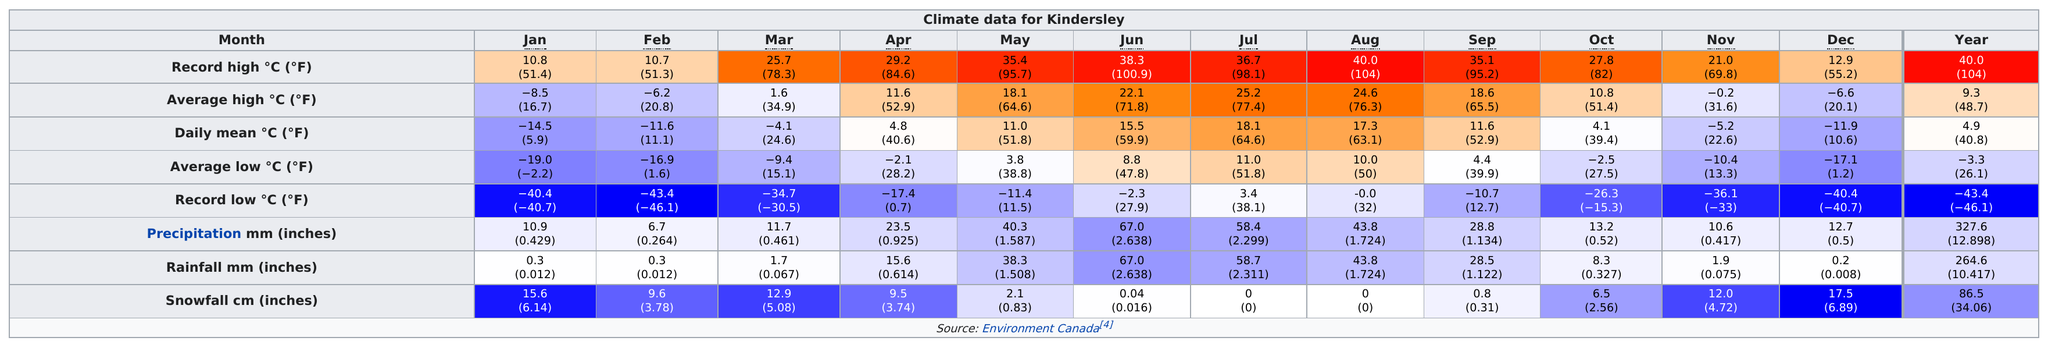Highlight a few significant elements in this photo. According to data, February is the month that averages the least amount of precipitation in Kindersley. Kindergarten students who attend school in areas with higher snowfall averages tend to receive more snowfall in the month before or after February than those who attend school in areas with lower snowfall averages. During the past 12 months, the daily mean temperature has exceeded 10 degrees Fahrenheit on average once per day. In December, the month recorded a high temperature of 12.9 degrees Celsius, while the average high temperature for the month was negative, indicating a significant deviation from the normal temperature range. June is the ideal month for individuals who appreciate the rain, as it provides ample opportunities to bask in the refreshing showers. 